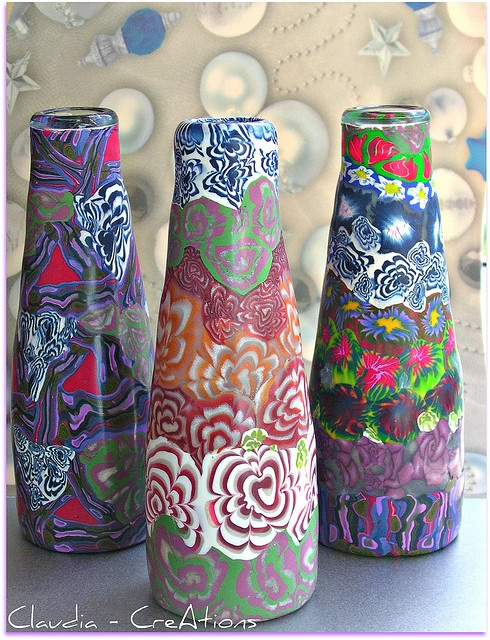Describe the objects in this image and their specific colors. I can see vase in white, darkgray, brown, and gray tones, vase in white, gray, and black tones, and vase in white, black, gray, and navy tones in this image. 